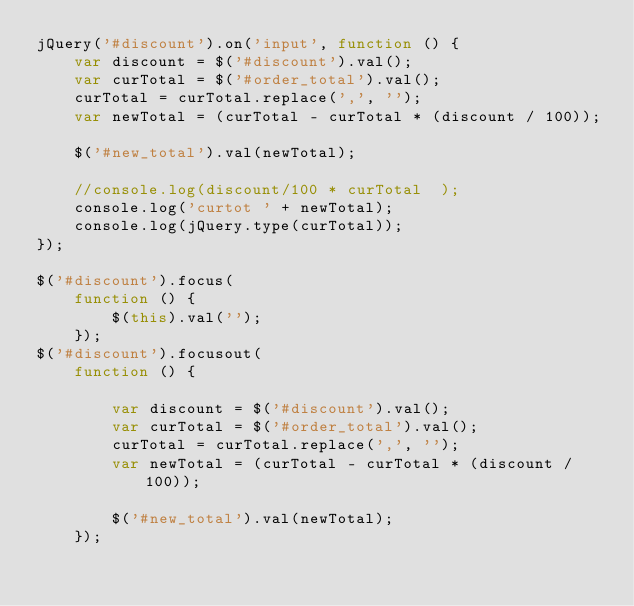<code> <loc_0><loc_0><loc_500><loc_500><_JavaScript_>jQuery('#discount').on('input', function () {
    var discount = $('#discount').val();
    var curTotal = $('#order_total').val();
    curTotal = curTotal.replace(',', '');
    var newTotal = (curTotal - curTotal * (discount / 100));

    $('#new_total').val(newTotal);

    //console.log(discount/100 * curTotal  );
    console.log('curtot ' + newTotal);
    console.log(jQuery.type(curTotal));
});

$('#discount').focus(
    function () {
        $(this).val('');
    });
$('#discount').focusout(
    function () {

        var discount = $('#discount').val();
        var curTotal = $('#order_total').val();
        curTotal = curTotal.replace(',', '');
        var newTotal = (curTotal - curTotal * (discount / 100));

        $('#new_total').val(newTotal);
    });</code> 